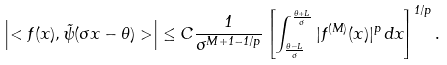<formula> <loc_0><loc_0><loc_500><loc_500>\left | < f ( x ) , \tilde { \psi } ( \sigma x - \theta ) > \right | \leq C \frac { 1 } { \sigma ^ { M + 1 - 1 / p } } \left [ \int _ { \frac { \theta - L } { \sigma } } ^ { \frac { \theta + L } { \sigma } } | f ^ { ( M ) } ( x ) | ^ { p } \, d x \right ] ^ { 1 / p } .</formula> 